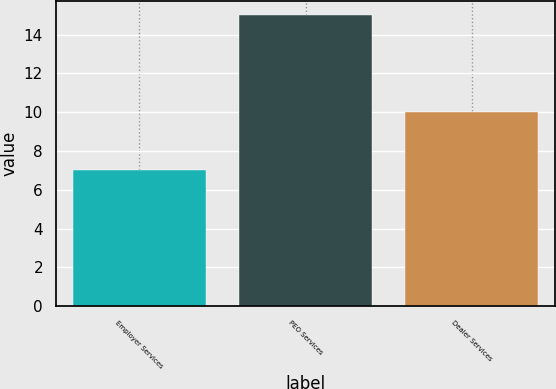Convert chart to OTSL. <chart><loc_0><loc_0><loc_500><loc_500><bar_chart><fcel>Employer Services<fcel>PEO Services<fcel>Dealer Services<nl><fcel>7<fcel>15<fcel>10<nl></chart> 